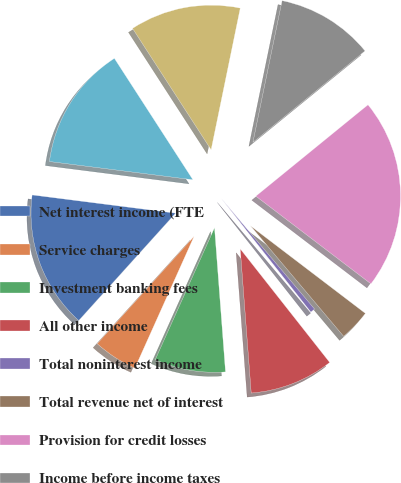<chart> <loc_0><loc_0><loc_500><loc_500><pie_chart><fcel>Net interest income (FTE<fcel>Service charges<fcel>Investment banking fees<fcel>All other income<fcel>Total noninterest income<fcel>Total revenue net of interest<fcel>Provision for credit losses<fcel>Income before income taxes<fcel>Income tax expense (FTE basis)<fcel>Net income<nl><fcel>15.33%<fcel>4.97%<fcel>7.93%<fcel>9.41%<fcel>0.53%<fcel>3.49%<fcel>21.25%<fcel>10.89%<fcel>12.37%<fcel>13.85%<nl></chart> 